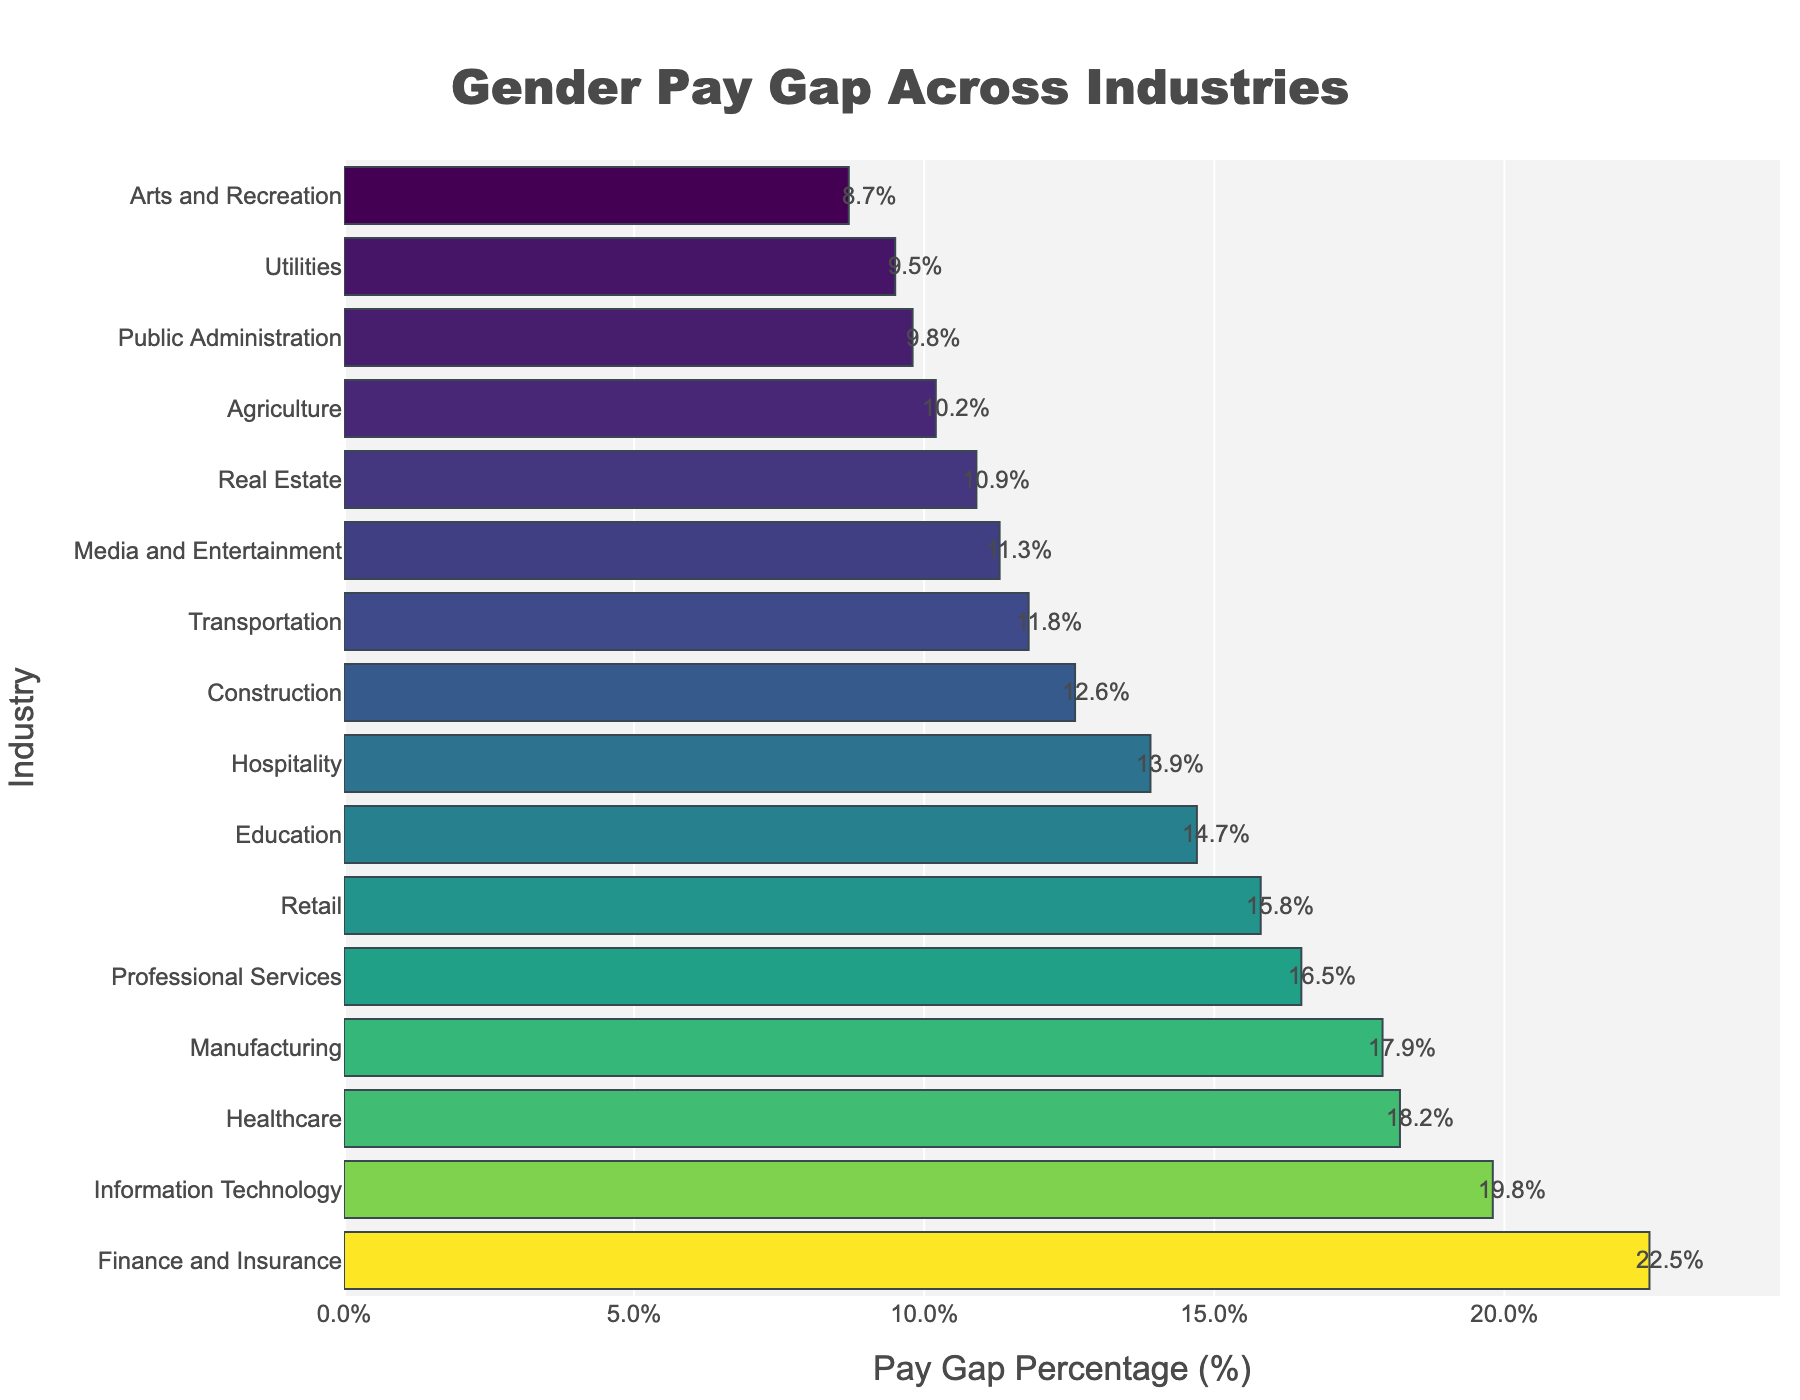What industry has the highest gender pay gap? The industry with the highest bar length represents the highest gender pay gap percentage. In the bar chart, "Finance and Insurance" has the highest bar, indicating the highest pay gap.
Answer: Finance and Insurance How much larger is the pay gap in the Finance and Insurance industry compared to the Construction industry? Find the pay gap percentage for both industries: Finance and Insurance (22.5%) and Construction (12.6%). Subtract the smaller pay gap percentage from the larger one: 22.5% - 12.6% = 9.9%.
Answer: 9.9% What is the median pay gap percentage across all industries? List the pay gap percentages in ascending order: [8.7, 9.5, 9.8, 10.2, 10.9, 11.3, 11.8, 12.6, 13.9, 14.7, 15.8, 16.5, 17.9, 18.2, 19.8, 22.5]. The median is the average of the 8th and 9th values: (12.6 + 13.9) / 2 = 13.25%.
Answer: 13.25% Which industry has a smaller pay gap: Healthcare or Retail? Compare the bar lengths for the Healthcare and Retail industries. Healthcare has a pay gap of 18.2%, and Retail has a pay gap of 15.8%. Retail has a smaller pay gap.
Answer: Retail How many industries have a gender pay gap of 15% or more? Count the number of bars that exceed 15% on the x-axis. The industries are Finance and Insurance, Information Technology, Healthcare, Manufacturing, Professional Services, and Retail. There are 6 industries.
Answer: 6 What is the total pay gap percentage sum of the top three industries with the highest pay gaps? Identify the top three industries: Finance and Insurance (22.5%), Information Technology (19.8%), and Healthcare (18.2%). Sum the percentages: 22.5 + 19.8 + 18.2 = 60.5%.
Answer: 60.5% How does the pay gap in the Transportation industry compare to that in the Media and Entertainment industry? Compare the pay gap percentages: Transportation has an 11.8% pay gap, and Media and Entertainment has an 11.3% pay gap. The Transportation industry has a slightly higher pay gap.
Answer: Transportation has a higher pay gap Which industries have a pay gap percentage of less than 10%? Look for bars ending before the 10% mark: Public Administration (9.8%), Utilities (9.5%), and Arts and Recreation (8.7%).
Answer: Public Administration, Utilities, and Arts and Recreation What is the average pay gap percentage for the industries shown? Sum all the pay gap percentages and divide by the number of industries: (22.5 + 19.8 + 18.2 + 17.9 + 16.5 + 15.8 + 14.7 + 13.9 + 12.6 + 11.8 + 11.3 + 10.9 + 10.2 + 9.8 + 9.5 + 8.7) / 16 = 13.95%.
Answer: 13.95% What is the difference in pay gap percentage between the Education industry and the Hospitality industry? Compare the two industries: Education has a 14.7% pay gap, and Hospitality has a 13.9% pay gap. Subtract the smaller from the larger: 14.7% - 13.9% = 0.8%.
Answer: 0.8% 